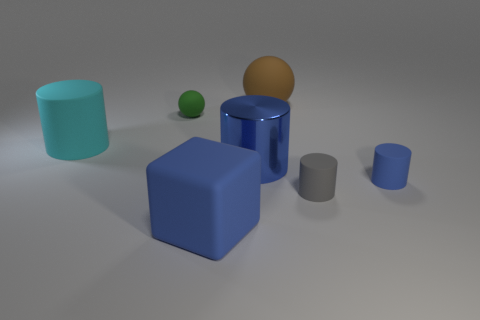Subtract all large blue cylinders. How many cylinders are left? 3 Subtract all yellow blocks. How many blue cylinders are left? 2 Add 3 big brown objects. How many objects exist? 10 Subtract 2 spheres. How many spheres are left? 0 Subtract all blue cylinders. How many cylinders are left? 2 Subtract all big blocks. Subtract all blue things. How many objects are left? 3 Add 5 rubber spheres. How many rubber spheres are left? 7 Add 1 blue rubber balls. How many blue rubber balls exist? 1 Subtract 1 blue cubes. How many objects are left? 6 Subtract all balls. How many objects are left? 5 